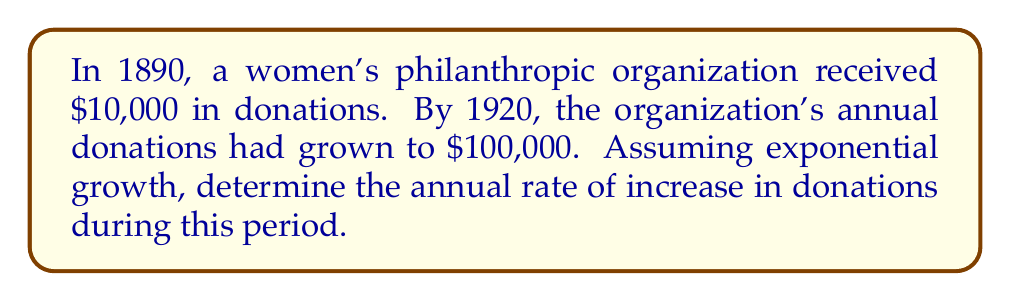Provide a solution to this math problem. To solve this problem, we'll use the exponential growth formula:

$$A = P(1 + r)^t$$

Where:
$A$ = Final amount ($100,000)
$P$ = Initial amount ($10,000)
$r$ = Annual rate of growth (to be determined)
$t$ = Time period (30 years, from 1890 to 1920)

Step 1: Substitute the known values into the formula
$$100,000 = 10,000(1 + r)^{30}$$

Step 2: Simplify the equation
$$10 = (1 + r)^{30}$$

Step 3: Take the 30th root of both sides
$$(10)^{\frac{1}{30}} = 1 + r$$

Step 4: Solve for r
$$r = (10)^{\frac{1}{30}} - 1$$

Step 5: Calculate the value of r
$$r \approx 1.0779 - 1 = 0.0779$$

Step 6: Convert to a percentage
$$0.0779 \times 100\% = 7.79\%$$
Answer: 7.79% 